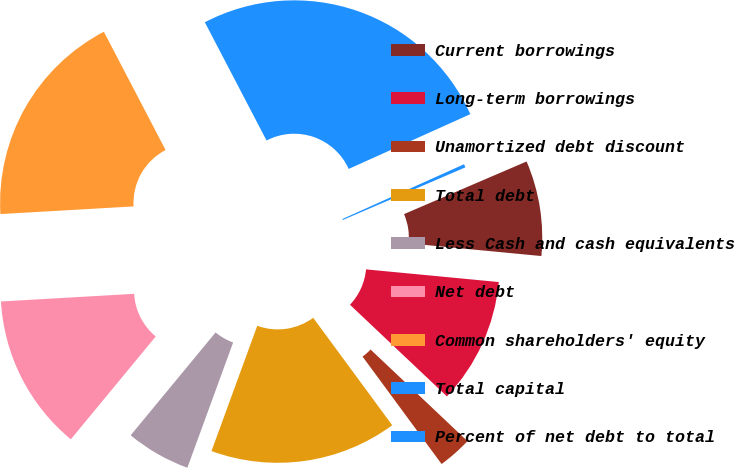Convert chart to OTSL. <chart><loc_0><loc_0><loc_500><loc_500><pie_chart><fcel>Current borrowings<fcel>Long-term borrowings<fcel>Unamortized debt discount<fcel>Total debt<fcel>Less Cash and cash equivalents<fcel>Net debt<fcel>Common shareholders' equity<fcel>Total capital<fcel>Percent of net debt to total<nl><fcel>7.97%<fcel>10.54%<fcel>2.85%<fcel>15.67%<fcel>5.41%<fcel>13.1%<fcel>18.26%<fcel>25.92%<fcel>0.28%<nl></chart> 